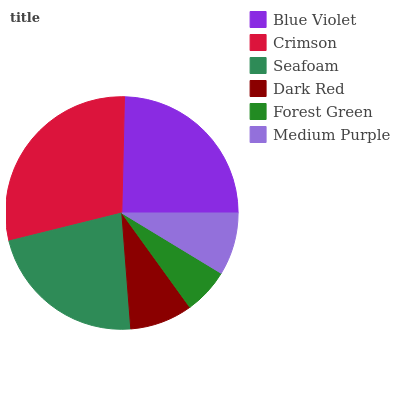Is Forest Green the minimum?
Answer yes or no. Yes. Is Crimson the maximum?
Answer yes or no. Yes. Is Seafoam the minimum?
Answer yes or no. No. Is Seafoam the maximum?
Answer yes or no. No. Is Crimson greater than Seafoam?
Answer yes or no. Yes. Is Seafoam less than Crimson?
Answer yes or no. Yes. Is Seafoam greater than Crimson?
Answer yes or no. No. Is Crimson less than Seafoam?
Answer yes or no. No. Is Seafoam the high median?
Answer yes or no. Yes. Is Dark Red the low median?
Answer yes or no. Yes. Is Dark Red the high median?
Answer yes or no. No. Is Crimson the low median?
Answer yes or no. No. 